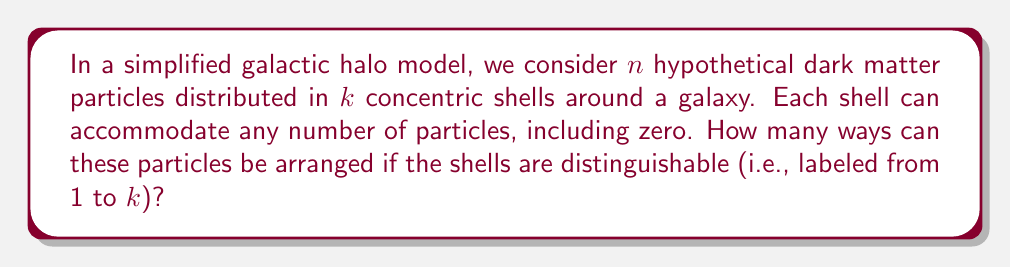Provide a solution to this math problem. Let's approach this problem step-by-step:

1) This is a classic stars and bars problem in combinatorics. We need to distribute $n$ indistinguishable objects (dark matter particles) into $k$ distinguishable boxes (shells).

2) In the stars and bars method, we represent each particle as a star (*) and use $k-1$ bars (|) to separate the $k$ shells.

3) The total number of symbols we need to arrange is:
   $n$ stars + $(k-1)$ bars = $n + k - 1$

4) The number of ways to arrange these symbols is equivalent to choosing the positions for either the stars or the bars. It's conventionally easier to choose the positions for the bars.

5) We need to choose $k-1$ positions for the bars out of the $n+k-1$ total positions. This is a combination problem.

6) The number of ways to do this is given by the combination formula:

   $$\binom{n+k-1}{k-1} = \frac{(n+k-1)!}{(k-1)!(n+k-1-(k-1))!} = \frac{(n+k-1)!}{(k-1)!n!}$$

This formula gives us the total number of ways to arrange the dark matter particles in the galactic halo model.
Answer: $\binom{n+k-1}{k-1}$ 